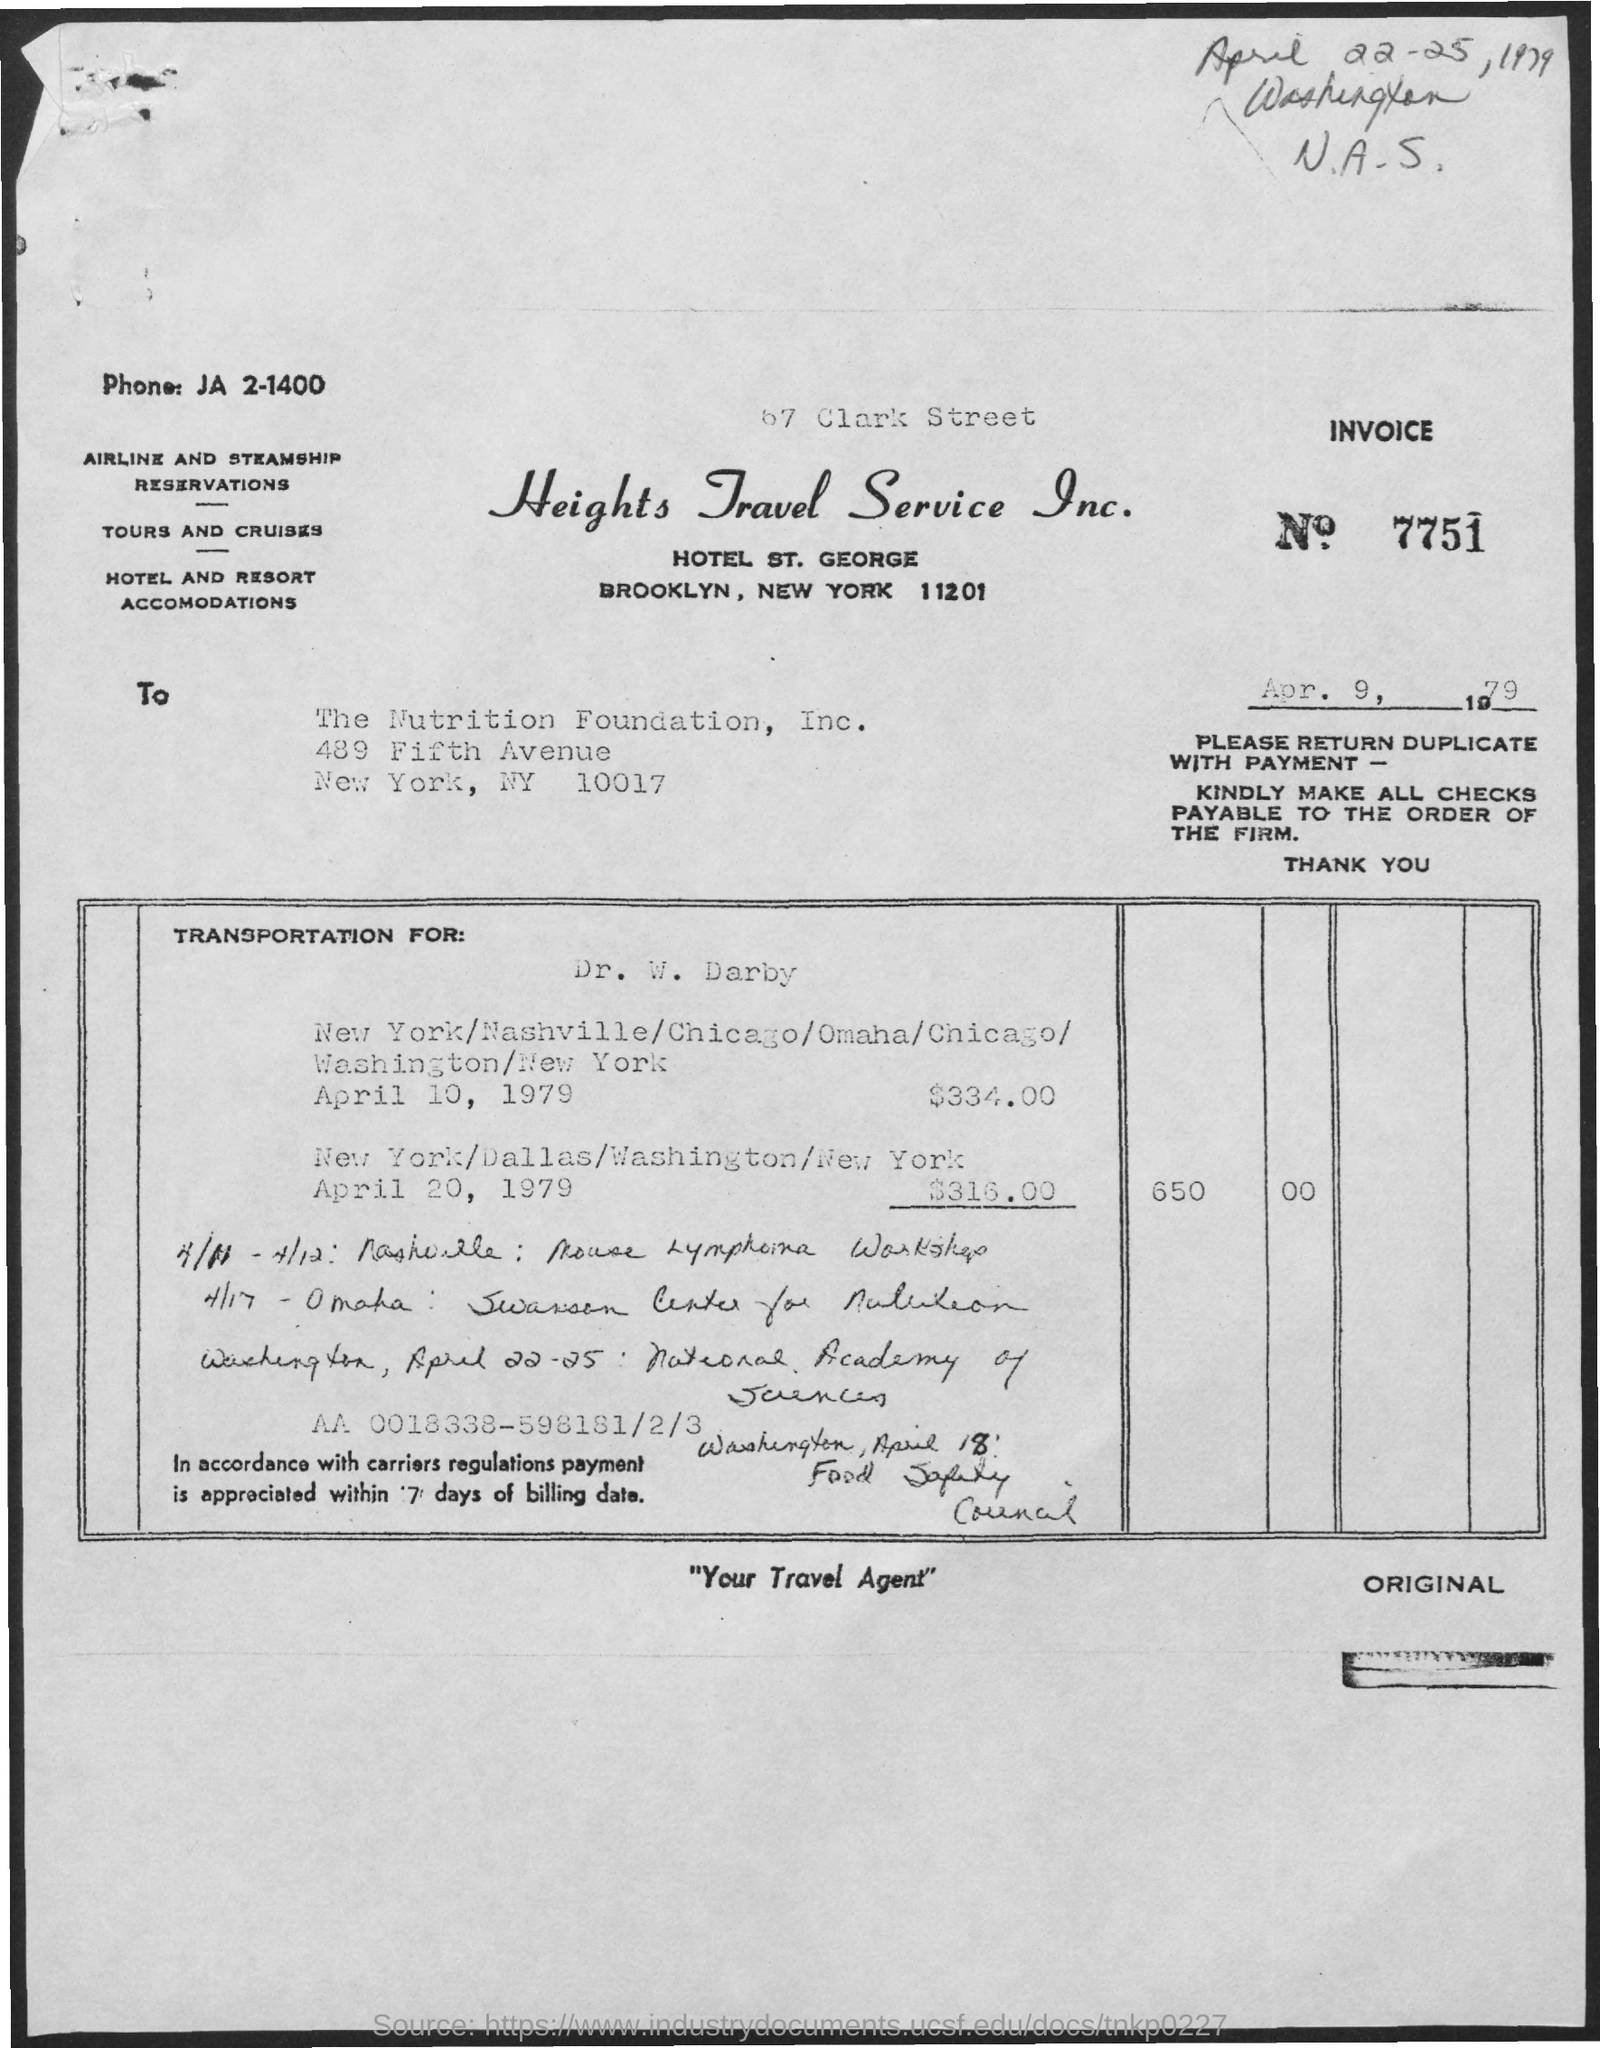Indicate a few pertinent items in this graphic. Heights Travel Service Inc. is the name of the travel service. 